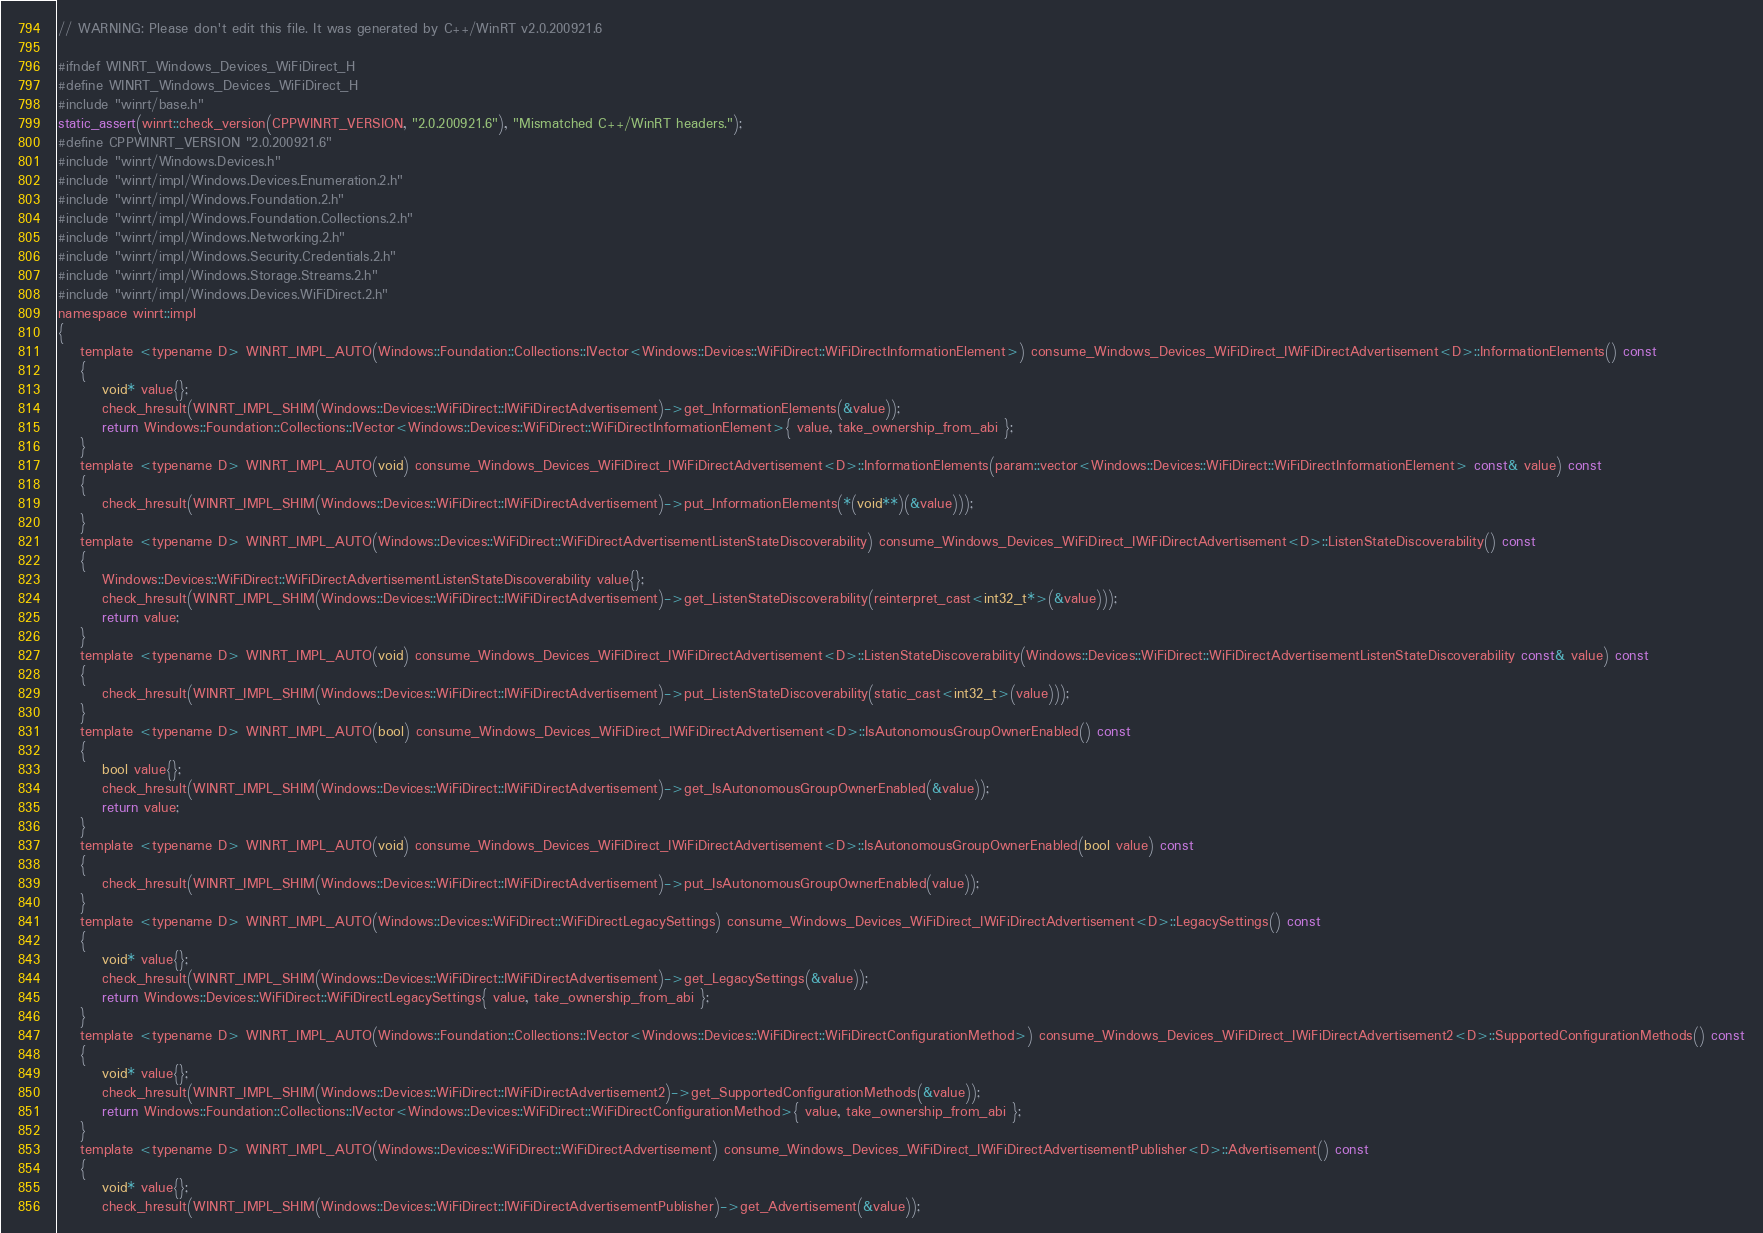<code> <loc_0><loc_0><loc_500><loc_500><_C_>// WARNING: Please don't edit this file. It was generated by C++/WinRT v2.0.200921.6

#ifndef WINRT_Windows_Devices_WiFiDirect_H
#define WINRT_Windows_Devices_WiFiDirect_H
#include "winrt/base.h"
static_assert(winrt::check_version(CPPWINRT_VERSION, "2.0.200921.6"), "Mismatched C++/WinRT headers.");
#define CPPWINRT_VERSION "2.0.200921.6"
#include "winrt/Windows.Devices.h"
#include "winrt/impl/Windows.Devices.Enumeration.2.h"
#include "winrt/impl/Windows.Foundation.2.h"
#include "winrt/impl/Windows.Foundation.Collections.2.h"
#include "winrt/impl/Windows.Networking.2.h"
#include "winrt/impl/Windows.Security.Credentials.2.h"
#include "winrt/impl/Windows.Storage.Streams.2.h"
#include "winrt/impl/Windows.Devices.WiFiDirect.2.h"
namespace winrt::impl
{
    template <typename D> WINRT_IMPL_AUTO(Windows::Foundation::Collections::IVector<Windows::Devices::WiFiDirect::WiFiDirectInformationElement>) consume_Windows_Devices_WiFiDirect_IWiFiDirectAdvertisement<D>::InformationElements() const
    {
        void* value{};
        check_hresult(WINRT_IMPL_SHIM(Windows::Devices::WiFiDirect::IWiFiDirectAdvertisement)->get_InformationElements(&value));
        return Windows::Foundation::Collections::IVector<Windows::Devices::WiFiDirect::WiFiDirectInformationElement>{ value, take_ownership_from_abi };
    }
    template <typename D> WINRT_IMPL_AUTO(void) consume_Windows_Devices_WiFiDirect_IWiFiDirectAdvertisement<D>::InformationElements(param::vector<Windows::Devices::WiFiDirect::WiFiDirectInformationElement> const& value) const
    {
        check_hresult(WINRT_IMPL_SHIM(Windows::Devices::WiFiDirect::IWiFiDirectAdvertisement)->put_InformationElements(*(void**)(&value)));
    }
    template <typename D> WINRT_IMPL_AUTO(Windows::Devices::WiFiDirect::WiFiDirectAdvertisementListenStateDiscoverability) consume_Windows_Devices_WiFiDirect_IWiFiDirectAdvertisement<D>::ListenStateDiscoverability() const
    {
        Windows::Devices::WiFiDirect::WiFiDirectAdvertisementListenStateDiscoverability value{};
        check_hresult(WINRT_IMPL_SHIM(Windows::Devices::WiFiDirect::IWiFiDirectAdvertisement)->get_ListenStateDiscoverability(reinterpret_cast<int32_t*>(&value)));
        return value;
    }
    template <typename D> WINRT_IMPL_AUTO(void) consume_Windows_Devices_WiFiDirect_IWiFiDirectAdvertisement<D>::ListenStateDiscoverability(Windows::Devices::WiFiDirect::WiFiDirectAdvertisementListenStateDiscoverability const& value) const
    {
        check_hresult(WINRT_IMPL_SHIM(Windows::Devices::WiFiDirect::IWiFiDirectAdvertisement)->put_ListenStateDiscoverability(static_cast<int32_t>(value)));
    }
    template <typename D> WINRT_IMPL_AUTO(bool) consume_Windows_Devices_WiFiDirect_IWiFiDirectAdvertisement<D>::IsAutonomousGroupOwnerEnabled() const
    {
        bool value{};
        check_hresult(WINRT_IMPL_SHIM(Windows::Devices::WiFiDirect::IWiFiDirectAdvertisement)->get_IsAutonomousGroupOwnerEnabled(&value));
        return value;
    }
    template <typename D> WINRT_IMPL_AUTO(void) consume_Windows_Devices_WiFiDirect_IWiFiDirectAdvertisement<D>::IsAutonomousGroupOwnerEnabled(bool value) const
    {
        check_hresult(WINRT_IMPL_SHIM(Windows::Devices::WiFiDirect::IWiFiDirectAdvertisement)->put_IsAutonomousGroupOwnerEnabled(value));
    }
    template <typename D> WINRT_IMPL_AUTO(Windows::Devices::WiFiDirect::WiFiDirectLegacySettings) consume_Windows_Devices_WiFiDirect_IWiFiDirectAdvertisement<D>::LegacySettings() const
    {
        void* value{};
        check_hresult(WINRT_IMPL_SHIM(Windows::Devices::WiFiDirect::IWiFiDirectAdvertisement)->get_LegacySettings(&value));
        return Windows::Devices::WiFiDirect::WiFiDirectLegacySettings{ value, take_ownership_from_abi };
    }
    template <typename D> WINRT_IMPL_AUTO(Windows::Foundation::Collections::IVector<Windows::Devices::WiFiDirect::WiFiDirectConfigurationMethod>) consume_Windows_Devices_WiFiDirect_IWiFiDirectAdvertisement2<D>::SupportedConfigurationMethods() const
    {
        void* value{};
        check_hresult(WINRT_IMPL_SHIM(Windows::Devices::WiFiDirect::IWiFiDirectAdvertisement2)->get_SupportedConfigurationMethods(&value));
        return Windows::Foundation::Collections::IVector<Windows::Devices::WiFiDirect::WiFiDirectConfigurationMethod>{ value, take_ownership_from_abi };
    }
    template <typename D> WINRT_IMPL_AUTO(Windows::Devices::WiFiDirect::WiFiDirectAdvertisement) consume_Windows_Devices_WiFiDirect_IWiFiDirectAdvertisementPublisher<D>::Advertisement() const
    {
        void* value{};
        check_hresult(WINRT_IMPL_SHIM(Windows::Devices::WiFiDirect::IWiFiDirectAdvertisementPublisher)->get_Advertisement(&value));</code> 